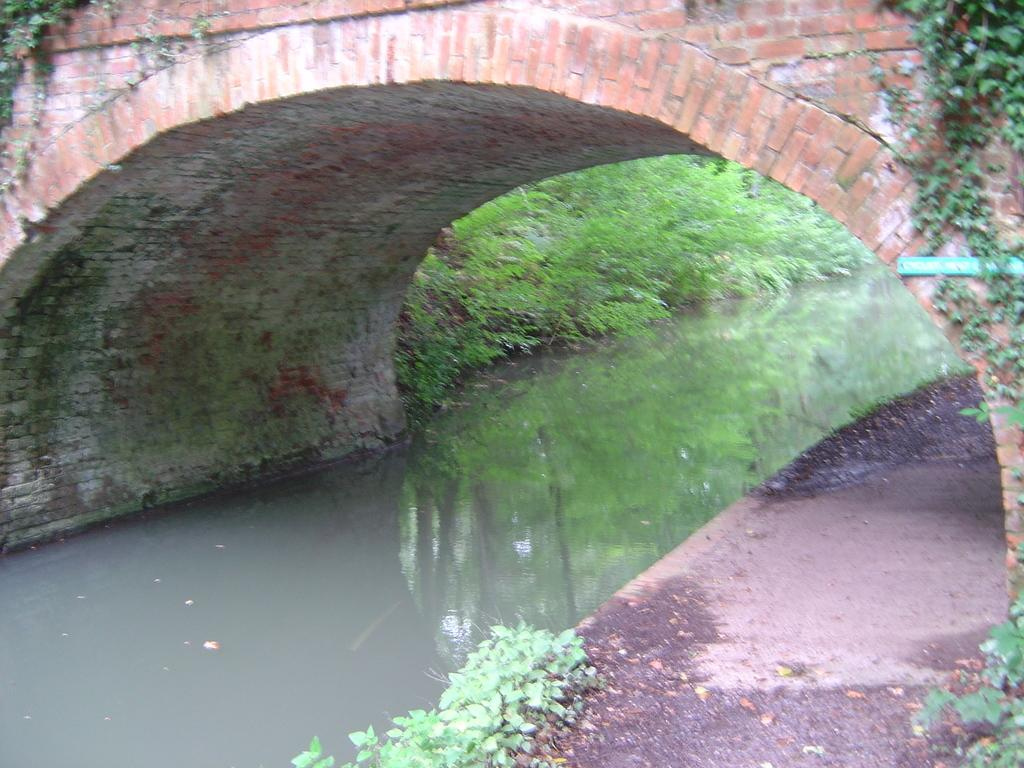What type of area is located at the bottom of the image? There is a drainage water area at the bottom of the image. What can be seen in the background of the image? There are plants in the background of the image. What structure is located at the top of the image? There is a bridge at the top of the image. How many houses are visible on top of the bridge in the image? There are no houses visible on top of the bridge in the image. Can you describe the duck that is swimming in the drainage water area? There is no duck present in the image; it features a drainage water area, plants, and a bridge. 